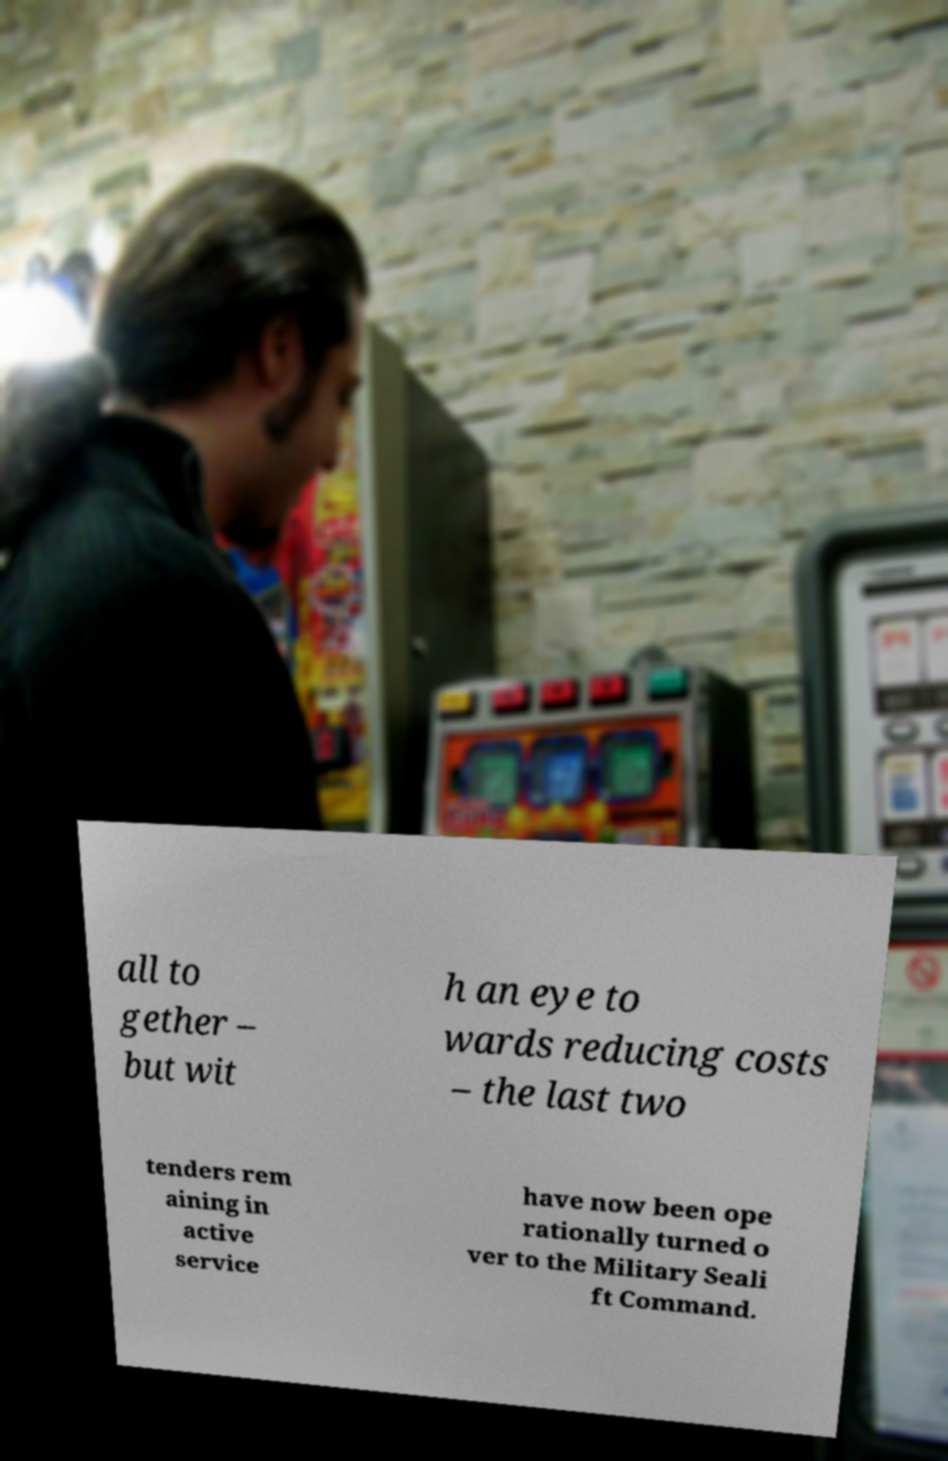What messages or text are displayed in this image? I need them in a readable, typed format. all to gether – but wit h an eye to wards reducing costs – the last two tenders rem aining in active service have now been ope rationally turned o ver to the Military Seali ft Command. 